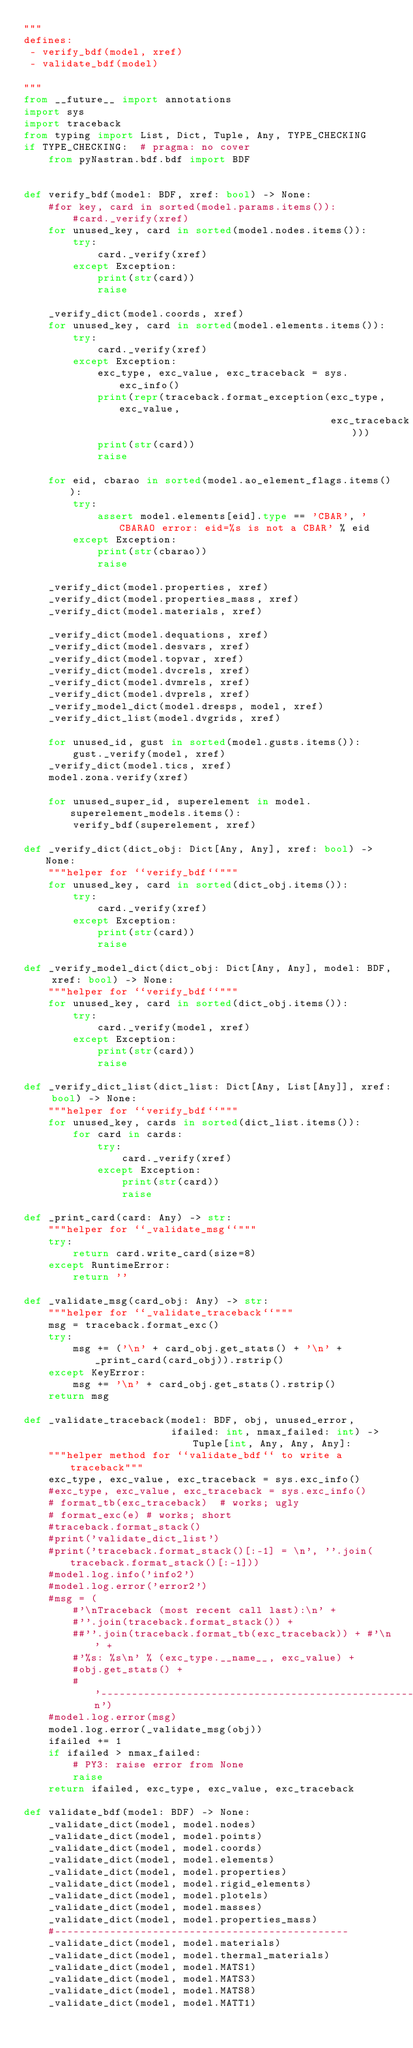<code> <loc_0><loc_0><loc_500><loc_500><_Python_>"""
defines:
 - verify_bdf(model, xref)
 - validate_bdf(model)

"""
from __future__ import annotations
import sys
import traceback
from typing import List, Dict, Tuple, Any, TYPE_CHECKING
if TYPE_CHECKING:  # pragma: no cover
    from pyNastran.bdf.bdf import BDF


def verify_bdf(model: BDF, xref: bool) -> None:
    #for key, card in sorted(model.params.items()):
        #card._verify(xref)
    for unused_key, card in sorted(model.nodes.items()):
        try:
            card._verify(xref)
        except Exception:
            print(str(card))
            raise

    _verify_dict(model.coords, xref)
    for unused_key, card in sorted(model.elements.items()):
        try:
            card._verify(xref)
        except Exception:
            exc_type, exc_value, exc_traceback = sys.exc_info()
            print(repr(traceback.format_exception(exc_type, exc_value,
                                                  exc_traceback)))
            print(str(card))
            raise

    for eid, cbarao in sorted(model.ao_element_flags.items()):
        try:
            assert model.elements[eid].type == 'CBAR', 'CBARAO error: eid=%s is not a CBAR' % eid
        except Exception:
            print(str(cbarao))
            raise

    _verify_dict(model.properties, xref)
    _verify_dict(model.properties_mass, xref)
    _verify_dict(model.materials, xref)

    _verify_dict(model.dequations, xref)
    _verify_dict(model.desvars, xref)
    _verify_dict(model.topvar, xref)
    _verify_dict(model.dvcrels, xref)
    _verify_dict(model.dvmrels, xref)
    _verify_dict(model.dvprels, xref)
    _verify_model_dict(model.dresps, model, xref)
    _verify_dict_list(model.dvgrids, xref)

    for unused_id, gust in sorted(model.gusts.items()):
        gust._verify(model, xref)
    _verify_dict(model.tics, xref)
    model.zona.verify(xref)

    for unused_super_id, superelement in model.superelement_models.items():
        verify_bdf(superelement, xref)

def _verify_dict(dict_obj: Dict[Any, Any], xref: bool) -> None:
    """helper for ``verify_bdf``"""
    for unused_key, card in sorted(dict_obj.items()):
        try:
            card._verify(xref)
        except Exception:
            print(str(card))
            raise

def _verify_model_dict(dict_obj: Dict[Any, Any], model: BDF, xref: bool) -> None:
    """helper for ``verify_bdf``"""
    for unused_key, card in sorted(dict_obj.items()):
        try:
            card._verify(model, xref)
        except Exception:
            print(str(card))
            raise

def _verify_dict_list(dict_list: Dict[Any, List[Any]], xref: bool) -> None:
    """helper for ``verify_bdf``"""
    for unused_key, cards in sorted(dict_list.items()):
        for card in cards:
            try:
                card._verify(xref)
            except Exception:
                print(str(card))
                raise

def _print_card(card: Any) -> str:
    """helper for ``_validate_msg``"""
    try:
        return card.write_card(size=8)
    except RuntimeError:
        return ''

def _validate_msg(card_obj: Any) -> str:
    """helper for ``_validate_traceback``"""
    msg = traceback.format_exc()
    try:
        msg += ('\n' + card_obj.get_stats() + '\n' + _print_card(card_obj)).rstrip()
    except KeyError:
        msg += '\n' + card_obj.get_stats().rstrip()
    return msg

def _validate_traceback(model: BDF, obj, unused_error,
                        ifailed: int, nmax_failed: int) -> Tuple[int, Any, Any, Any]:
    """helper method for ``validate_bdf`` to write a traceback"""
    exc_type, exc_value, exc_traceback = sys.exc_info()
    #exc_type, exc_value, exc_traceback = sys.exc_info()
    # format_tb(exc_traceback)  # works; ugly
    # format_exc(e) # works; short
    #traceback.format_stack()
    #print('validate_dict_list')
    #print('traceback.format_stack()[:-1] = \n', ''.join(traceback.format_stack()[:-1]))
    #model.log.info('info2')
    #model.log.error('error2')
    #msg = (
        #'\nTraceback (most recent call last):\n' +
        #''.join(traceback.format_stack()) +
        ##''.join(traceback.format_tb(exc_traceback)) + #'\n' +
        #'%s: %s\n' % (exc_type.__name__, exc_value) +
        #obj.get_stats() +
        #'----------------------------------------------------------------\n')
    #model.log.error(msg)
    model.log.error(_validate_msg(obj))
    ifailed += 1
    if ifailed > nmax_failed:
        # PY3: raise error from None
        raise
    return ifailed, exc_type, exc_value, exc_traceback

def validate_bdf(model: BDF) -> None:
    _validate_dict(model, model.nodes)
    _validate_dict(model, model.points)
    _validate_dict(model, model.coords)
    _validate_dict(model, model.elements)
    _validate_dict(model, model.properties)
    _validate_dict(model, model.rigid_elements)
    _validate_dict(model, model.plotels)
    _validate_dict(model, model.masses)
    _validate_dict(model, model.properties_mass)
    #------------------------------------------------
    _validate_dict(model, model.materials)
    _validate_dict(model, model.thermal_materials)
    _validate_dict(model, model.MATS1)
    _validate_dict(model, model.MATS3)
    _validate_dict(model, model.MATS8)
    _validate_dict(model, model.MATT1)</code> 